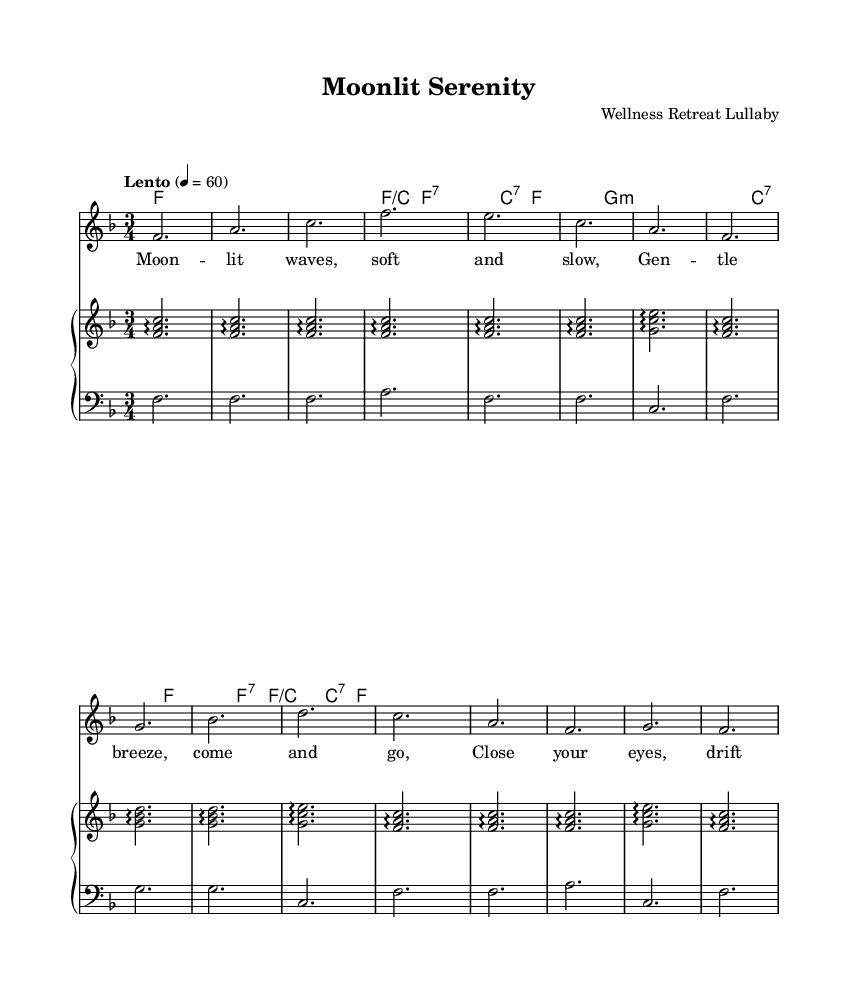What is the key signature of this music? The key signature indicates the key of F major, which has one flat note (B flat). This can be determined by looking at the beginning of the staff where the flat is indicated.
Answer: F major What is the time signature of this piece? The time signature, found at the beginning of the sheet music, indicates that this piece is in 3/4 time, which means there are three beats in each measure and the quarter note gets one beat.
Answer: 3/4 What is the tempo marking given for this music? The tempo marking, found at the start of the score, specifies "Lento," which indicates a slow pace. The metronome marking of 4 = 60 confirms this by indicating that there are 60 beats per minute.
Answer: Lento How many measures are in the piece? Counting the visible measures in the score reveals there are sixteen measures total, located between the clefs for the melody and harmonies.
Answer: 16 measures What is the main theme or mood conveyed by the lyrics? The lyrics suggest a calming and gentle atmosphere, promoting relaxation and peacefulness, consistent with the theme of a lullaby to aid in winding down. This is supported by phrases like "drift away" and "peace will guide you."
Answer: Peaceful Which instruments are included in the arrangement? The arrangement features a piano (with both upper and lower staves) and a vocal part, as indicated by the sections labeled for the staff and voice.
Answer: Piano and voice What type of operatic structure is represented in this lullaby? The piece incorporates characteristics of arias, as it allows a solo vocal line to express emotions without dialogue, focusing instead on melodic lines supported by harmonic chords.
Answer: Arias 